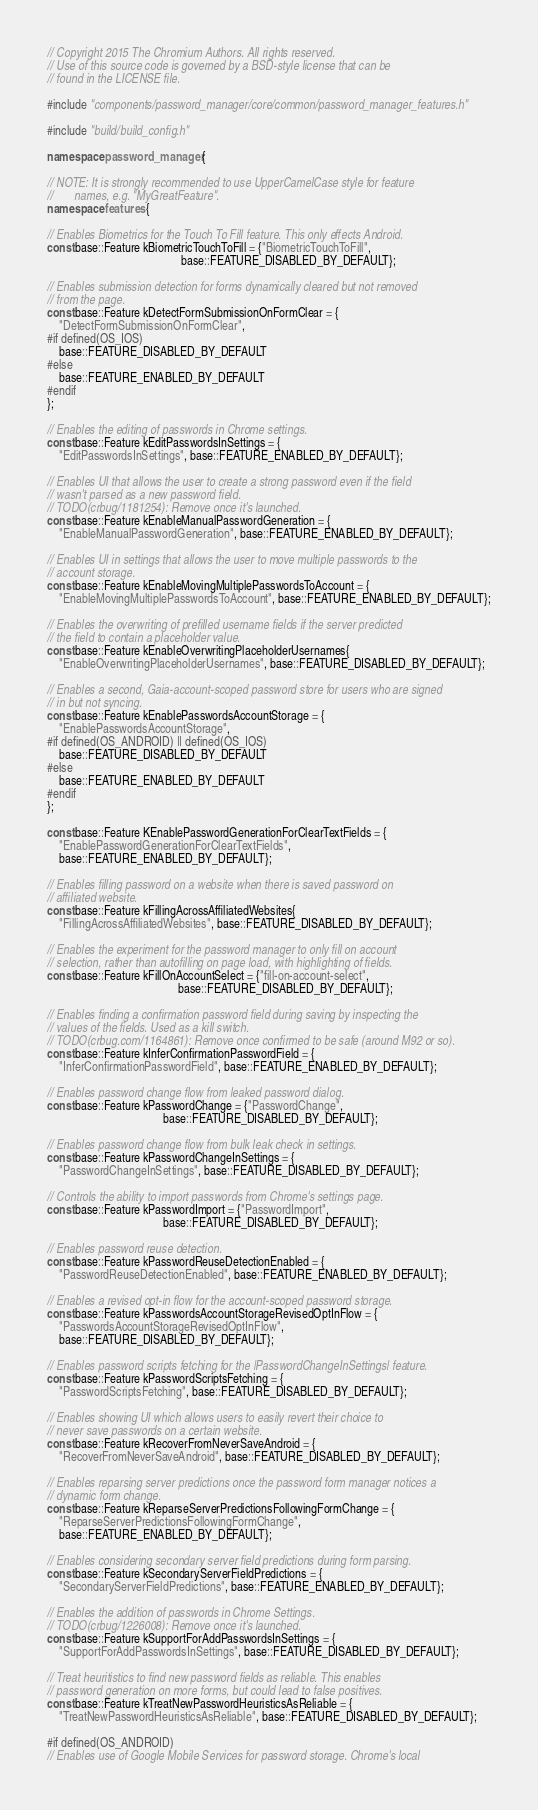<code> <loc_0><loc_0><loc_500><loc_500><_C++_>// Copyright 2015 The Chromium Authors. All rights reserved.
// Use of this source code is governed by a BSD-style license that can be
// found in the LICENSE file.

#include "components/password_manager/core/common/password_manager_features.h"

#include "build/build_config.h"

namespace password_manager {

// NOTE: It is strongly recommended to use UpperCamelCase style for feature
//       names, e.g. "MyGreatFeature".
namespace features {

// Enables Biometrics for the Touch To Fill feature. This only effects Android.
const base::Feature kBiometricTouchToFill = {"BiometricTouchToFill",
                                             base::FEATURE_DISABLED_BY_DEFAULT};

// Enables submission detection for forms dynamically cleared but not removed
// from the page.
const base::Feature kDetectFormSubmissionOnFormClear = {
    "DetectFormSubmissionOnFormClear",
#if defined(OS_IOS)
    base::FEATURE_DISABLED_BY_DEFAULT
#else
    base::FEATURE_ENABLED_BY_DEFAULT
#endif
};

// Enables the editing of passwords in Chrome settings.
const base::Feature kEditPasswordsInSettings = {
    "EditPasswordsInSettings", base::FEATURE_ENABLED_BY_DEFAULT};

// Enables UI that allows the user to create a strong password even if the field
// wasn't parsed as a new password field.
// TODO(crbug/1181254): Remove once it's launched.
const base::Feature kEnableManualPasswordGeneration = {
    "EnableManualPasswordGeneration", base::FEATURE_ENABLED_BY_DEFAULT};

// Enables UI in settings that allows the user to move multiple passwords to the
// account storage.
const base::Feature kEnableMovingMultiplePasswordsToAccount = {
    "EnableMovingMultiplePasswordsToAccount", base::FEATURE_ENABLED_BY_DEFAULT};

// Enables the overwriting of prefilled username fields if the server predicted
// the field to contain a placeholder value.
const base::Feature kEnableOverwritingPlaceholderUsernames{
    "EnableOverwritingPlaceholderUsernames", base::FEATURE_DISABLED_BY_DEFAULT};

// Enables a second, Gaia-account-scoped password store for users who are signed
// in but not syncing.
const base::Feature kEnablePasswordsAccountStorage = {
    "EnablePasswordsAccountStorage",
#if defined(OS_ANDROID) || defined(OS_IOS)
    base::FEATURE_DISABLED_BY_DEFAULT
#else
    base::FEATURE_ENABLED_BY_DEFAULT
#endif
};

const base::Feature KEnablePasswordGenerationForClearTextFields = {
    "EnablePasswordGenerationForClearTextFields",
    base::FEATURE_ENABLED_BY_DEFAULT};

// Enables filling password on a website when there is saved password on
// affiliated website.
const base::Feature kFillingAcrossAffiliatedWebsites{
    "FillingAcrossAffiliatedWebsites", base::FEATURE_DISABLED_BY_DEFAULT};

// Enables the experiment for the password manager to only fill on account
// selection, rather than autofilling on page load, with highlighting of fields.
const base::Feature kFillOnAccountSelect = {"fill-on-account-select",
                                            base::FEATURE_DISABLED_BY_DEFAULT};

// Enables finding a confirmation password field during saving by inspecting the
// values of the fields. Used as a kill switch.
// TODO(crbug.com/1164861): Remove once confirmed to be safe (around M92 or so).
const base::Feature kInferConfirmationPasswordField = {
    "InferConfirmationPasswordField", base::FEATURE_ENABLED_BY_DEFAULT};

// Enables password change flow from leaked password dialog.
const base::Feature kPasswordChange = {"PasswordChange",
                                       base::FEATURE_DISABLED_BY_DEFAULT};

// Enables password change flow from bulk leak check in settings.
const base::Feature kPasswordChangeInSettings = {
    "PasswordChangeInSettings", base::FEATURE_DISABLED_BY_DEFAULT};

// Controls the ability to import passwords from Chrome's settings page.
const base::Feature kPasswordImport = {"PasswordImport",
                                       base::FEATURE_DISABLED_BY_DEFAULT};

// Enables password reuse detection.
const base::Feature kPasswordReuseDetectionEnabled = {
    "PasswordReuseDetectionEnabled", base::FEATURE_ENABLED_BY_DEFAULT};

// Enables a revised opt-in flow for the account-scoped password storage.
const base::Feature kPasswordsAccountStorageRevisedOptInFlow = {
    "PasswordsAccountStorageRevisedOptInFlow",
    base::FEATURE_DISABLED_BY_DEFAULT};

// Enables password scripts fetching for the |PasswordChangeInSettings| feature.
const base::Feature kPasswordScriptsFetching = {
    "PasswordScriptsFetching", base::FEATURE_DISABLED_BY_DEFAULT};

// Enables showing UI which allows users to easily revert their choice to
// never save passwords on a certain website.
const base::Feature kRecoverFromNeverSaveAndroid = {
    "RecoverFromNeverSaveAndroid", base::FEATURE_DISABLED_BY_DEFAULT};

// Enables reparsing server predictions once the password form manager notices a
// dynamic form change.
const base::Feature kReparseServerPredictionsFollowingFormChange = {
    "ReparseServerPredictionsFollowingFormChange",
    base::FEATURE_ENABLED_BY_DEFAULT};

// Enables considering secondary server field predictions during form parsing.
const base::Feature kSecondaryServerFieldPredictions = {
    "SecondaryServerFieldPredictions", base::FEATURE_ENABLED_BY_DEFAULT};

// Enables the addition of passwords in Chrome Settings.
// TODO(crbug/1226008): Remove once it's launched.
const base::Feature kSupportForAddPasswordsInSettings = {
    "SupportForAddPasswordsInSettings", base::FEATURE_DISABLED_BY_DEFAULT};

// Treat heuritistics to find new password fields as reliable. This enables
// password generation on more forms, but could lead to false positives.
const base::Feature kTreatNewPasswordHeuristicsAsReliable = {
    "TreatNewPasswordHeuristicsAsReliable", base::FEATURE_DISABLED_BY_DEFAULT};

#if defined(OS_ANDROID)
// Enables use of Google Mobile Services for password storage. Chrome's local</code> 